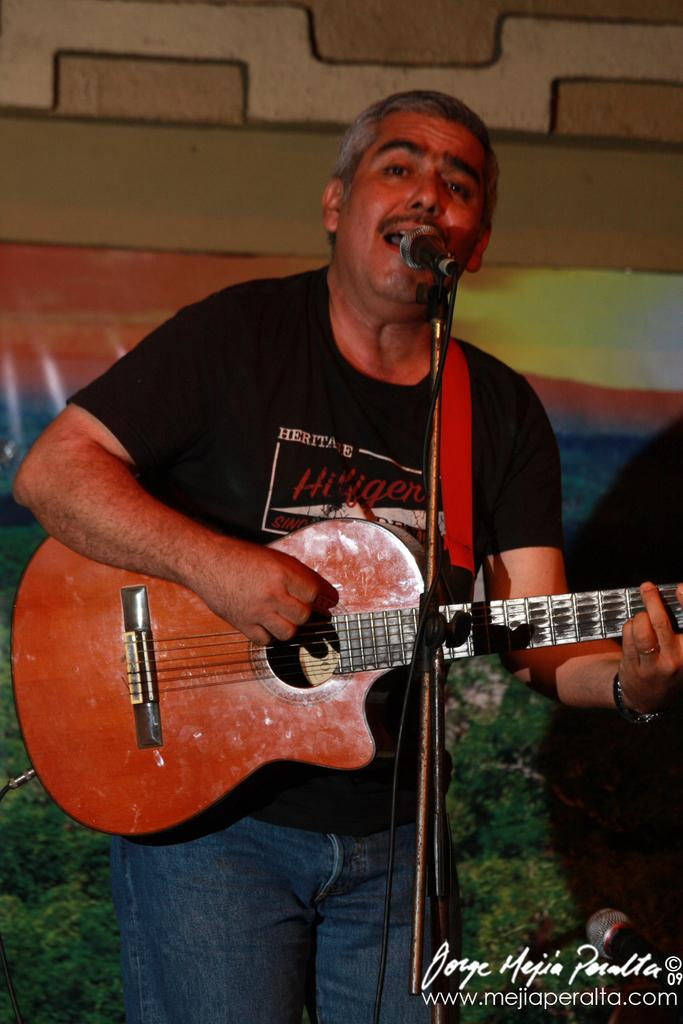What is the man in the image doing? The man is standing in the image and holding a guitar. What object is in front of the man? There is a microphone in front of the man. What can be seen in the background of the image? There is a wall and grass in the background of the image. Can you see a donkey playing basketball on the bridge in the image? No, there is no donkey, basketball, or bridge present in the image. 